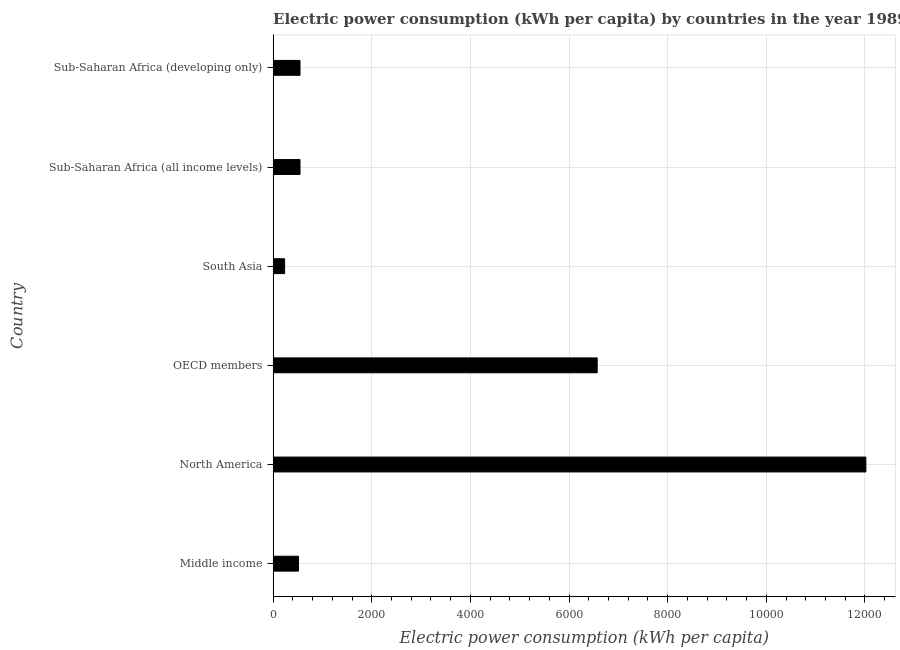Does the graph contain any zero values?
Offer a terse response. No. What is the title of the graph?
Keep it short and to the point. Electric power consumption (kWh per capita) by countries in the year 1989. What is the label or title of the X-axis?
Provide a short and direct response. Electric power consumption (kWh per capita). What is the electric power consumption in OECD members?
Offer a very short reply. 6570.75. Across all countries, what is the maximum electric power consumption?
Provide a short and direct response. 1.20e+04. Across all countries, what is the minimum electric power consumption?
Your response must be concise. 233.23. What is the sum of the electric power consumption?
Provide a short and direct response. 2.04e+04. What is the difference between the electric power consumption in Middle income and Sub-Saharan Africa (developing only)?
Provide a succinct answer. -30.6. What is the average electric power consumption per country?
Your response must be concise. 3404.55. What is the median electric power consumption?
Provide a short and direct response. 545.21. Is the difference between the electric power consumption in North America and OECD members greater than the difference between any two countries?
Your answer should be very brief. No. What is the difference between the highest and the second highest electric power consumption?
Offer a terse response. 5447.52. What is the difference between the highest and the lowest electric power consumption?
Your answer should be compact. 1.18e+04. In how many countries, is the electric power consumption greater than the average electric power consumption taken over all countries?
Your answer should be very brief. 2. How many bars are there?
Make the answer very short. 6. How many countries are there in the graph?
Ensure brevity in your answer.  6. Are the values on the major ticks of X-axis written in scientific E-notation?
Make the answer very short. No. What is the Electric power consumption (kWh per capita) of Middle income?
Offer a very short reply. 514.6. What is the Electric power consumption (kWh per capita) in North America?
Your answer should be compact. 1.20e+04. What is the Electric power consumption (kWh per capita) of OECD members?
Keep it short and to the point. 6570.75. What is the Electric power consumption (kWh per capita) in South Asia?
Ensure brevity in your answer.  233.23. What is the Electric power consumption (kWh per capita) in Sub-Saharan Africa (all income levels)?
Offer a terse response. 545.21. What is the Electric power consumption (kWh per capita) of Sub-Saharan Africa (developing only)?
Keep it short and to the point. 545.21. What is the difference between the Electric power consumption (kWh per capita) in Middle income and North America?
Make the answer very short. -1.15e+04. What is the difference between the Electric power consumption (kWh per capita) in Middle income and OECD members?
Provide a short and direct response. -6056.15. What is the difference between the Electric power consumption (kWh per capita) in Middle income and South Asia?
Your answer should be very brief. 281.37. What is the difference between the Electric power consumption (kWh per capita) in Middle income and Sub-Saharan Africa (all income levels)?
Provide a succinct answer. -30.6. What is the difference between the Electric power consumption (kWh per capita) in Middle income and Sub-Saharan Africa (developing only)?
Keep it short and to the point. -30.6. What is the difference between the Electric power consumption (kWh per capita) in North America and OECD members?
Your answer should be compact. 5447.52. What is the difference between the Electric power consumption (kWh per capita) in North America and South Asia?
Your response must be concise. 1.18e+04. What is the difference between the Electric power consumption (kWh per capita) in North America and Sub-Saharan Africa (all income levels)?
Your answer should be very brief. 1.15e+04. What is the difference between the Electric power consumption (kWh per capita) in North America and Sub-Saharan Africa (developing only)?
Your response must be concise. 1.15e+04. What is the difference between the Electric power consumption (kWh per capita) in OECD members and South Asia?
Offer a very short reply. 6337.52. What is the difference between the Electric power consumption (kWh per capita) in OECD members and Sub-Saharan Africa (all income levels)?
Offer a very short reply. 6025.55. What is the difference between the Electric power consumption (kWh per capita) in OECD members and Sub-Saharan Africa (developing only)?
Your answer should be very brief. 6025.55. What is the difference between the Electric power consumption (kWh per capita) in South Asia and Sub-Saharan Africa (all income levels)?
Your answer should be compact. -311.97. What is the difference between the Electric power consumption (kWh per capita) in South Asia and Sub-Saharan Africa (developing only)?
Keep it short and to the point. -311.97. What is the ratio of the Electric power consumption (kWh per capita) in Middle income to that in North America?
Ensure brevity in your answer.  0.04. What is the ratio of the Electric power consumption (kWh per capita) in Middle income to that in OECD members?
Your response must be concise. 0.08. What is the ratio of the Electric power consumption (kWh per capita) in Middle income to that in South Asia?
Offer a very short reply. 2.21. What is the ratio of the Electric power consumption (kWh per capita) in Middle income to that in Sub-Saharan Africa (all income levels)?
Your answer should be compact. 0.94. What is the ratio of the Electric power consumption (kWh per capita) in Middle income to that in Sub-Saharan Africa (developing only)?
Ensure brevity in your answer.  0.94. What is the ratio of the Electric power consumption (kWh per capita) in North America to that in OECD members?
Your response must be concise. 1.83. What is the ratio of the Electric power consumption (kWh per capita) in North America to that in South Asia?
Make the answer very short. 51.53. What is the ratio of the Electric power consumption (kWh per capita) in North America to that in Sub-Saharan Africa (all income levels)?
Ensure brevity in your answer.  22.04. What is the ratio of the Electric power consumption (kWh per capita) in North America to that in Sub-Saharan Africa (developing only)?
Provide a short and direct response. 22.04. What is the ratio of the Electric power consumption (kWh per capita) in OECD members to that in South Asia?
Offer a very short reply. 28.17. What is the ratio of the Electric power consumption (kWh per capita) in OECD members to that in Sub-Saharan Africa (all income levels)?
Your answer should be very brief. 12.05. What is the ratio of the Electric power consumption (kWh per capita) in OECD members to that in Sub-Saharan Africa (developing only)?
Offer a very short reply. 12.05. What is the ratio of the Electric power consumption (kWh per capita) in South Asia to that in Sub-Saharan Africa (all income levels)?
Your answer should be very brief. 0.43. What is the ratio of the Electric power consumption (kWh per capita) in South Asia to that in Sub-Saharan Africa (developing only)?
Your answer should be compact. 0.43. What is the ratio of the Electric power consumption (kWh per capita) in Sub-Saharan Africa (all income levels) to that in Sub-Saharan Africa (developing only)?
Provide a short and direct response. 1. 